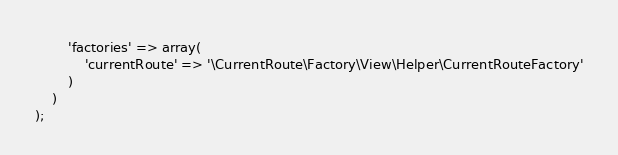Convert code to text. <code><loc_0><loc_0><loc_500><loc_500><_PHP_>        'factories' => array(
            'currentRoute' => '\CurrentRoute\Factory\View\Helper\CurrentRouteFactory'
        )
    )
);
</code> 